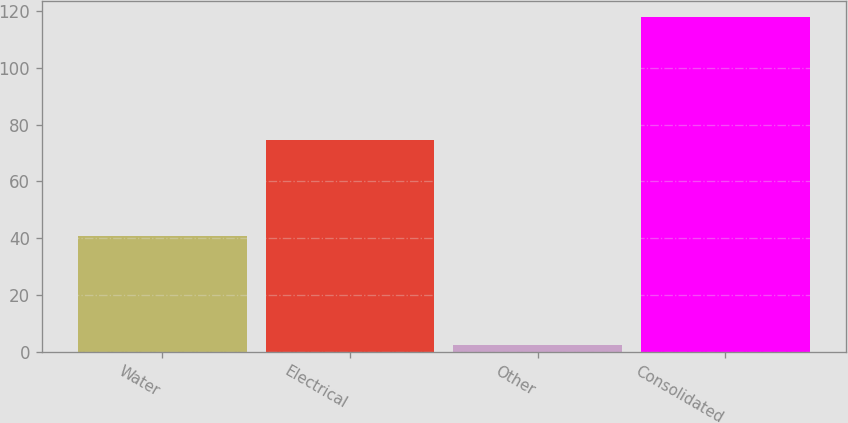Convert chart to OTSL. <chart><loc_0><loc_0><loc_500><loc_500><bar_chart><fcel>Water<fcel>Electrical<fcel>Other<fcel>Consolidated<nl><fcel>40.8<fcel>74.5<fcel>2.5<fcel>117.8<nl></chart> 